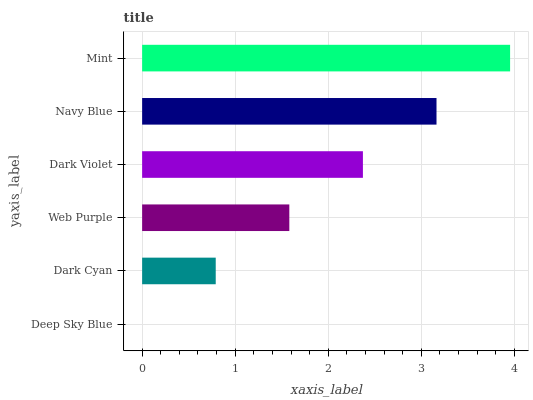Is Deep Sky Blue the minimum?
Answer yes or no. Yes. Is Mint the maximum?
Answer yes or no. Yes. Is Dark Cyan the minimum?
Answer yes or no. No. Is Dark Cyan the maximum?
Answer yes or no. No. Is Dark Cyan greater than Deep Sky Blue?
Answer yes or no. Yes. Is Deep Sky Blue less than Dark Cyan?
Answer yes or no. Yes. Is Deep Sky Blue greater than Dark Cyan?
Answer yes or no. No. Is Dark Cyan less than Deep Sky Blue?
Answer yes or no. No. Is Dark Violet the high median?
Answer yes or no. Yes. Is Web Purple the low median?
Answer yes or no. Yes. Is Mint the high median?
Answer yes or no. No. Is Dark Cyan the low median?
Answer yes or no. No. 